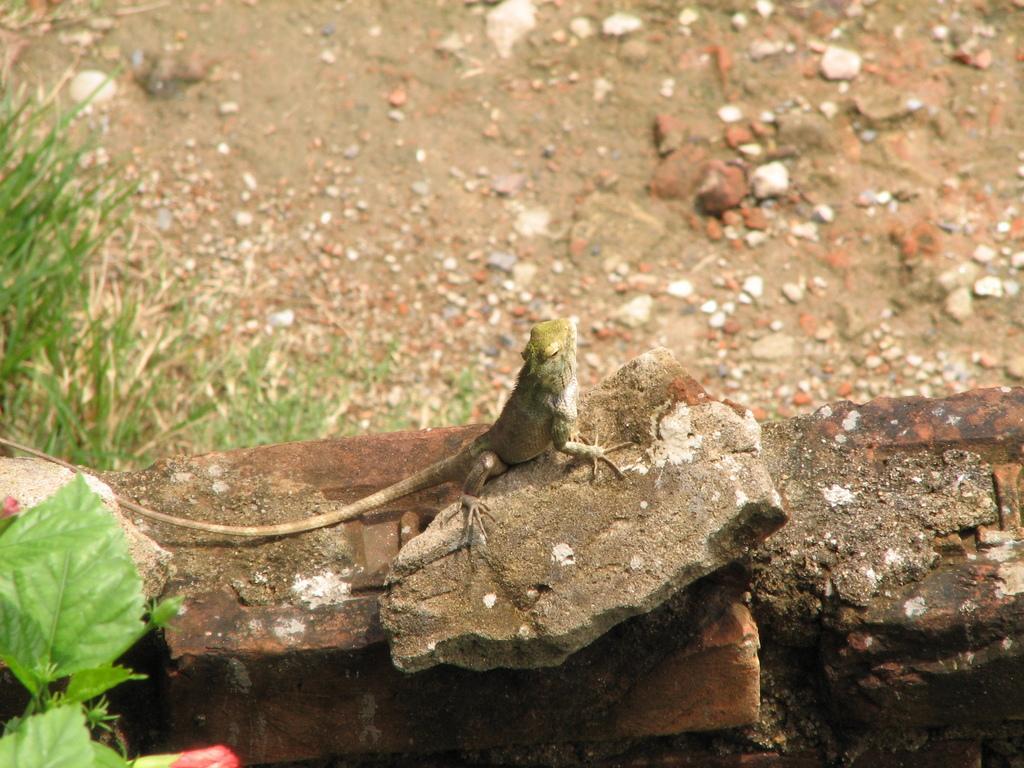Describe this image in one or two sentences. At the bottom of the image there are stones. On the stones there is a garden lizard. In the bottom left corner of the image there are leaves and also there is a flower. Behind the stones on the ground there are stones and also there is grass. 